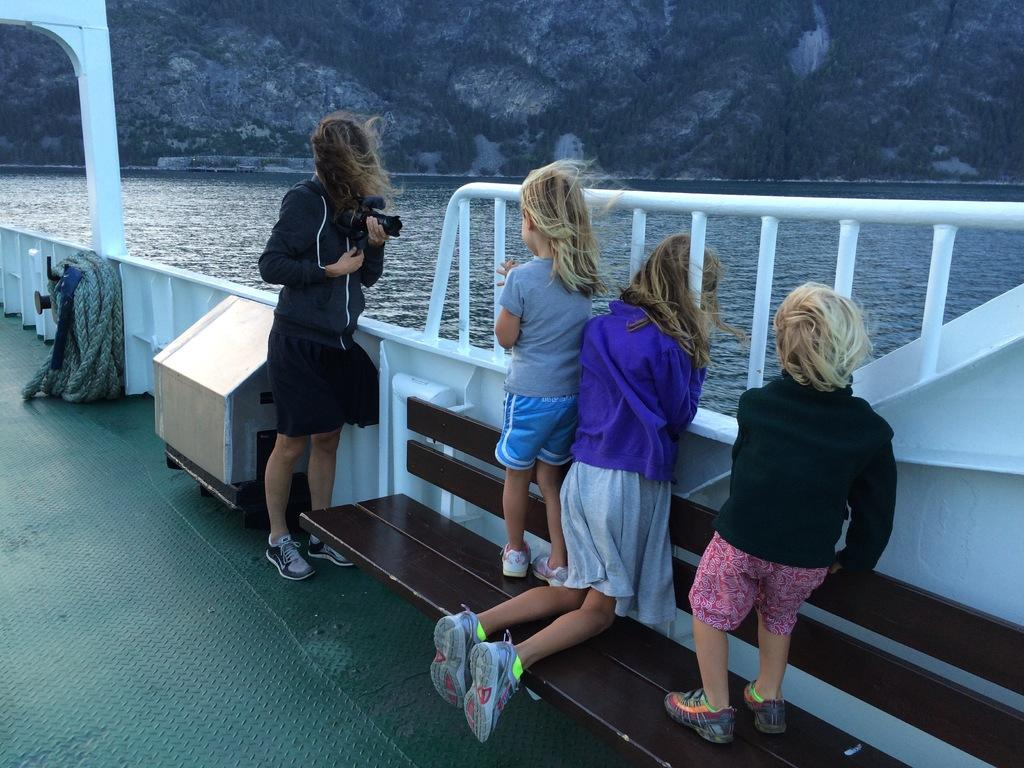How many people are in the image? There are people in the image, but the exact number is not specified. What can be observed about the clothing of the people in the image? The people are wearing different color dresses. What is one person doing in the image? One person is holding a camera. Where are the people located in the image? The people are inside a white boat. What is attached to the boat in the image? There is a rope visible in the image. What can be seen in the background of the image? There is water and mountains visible in the image. What type of plantation can be seen in the image? There is no plantation present in the image. How does the temper of the people in the image compare to the temper of the mountains? The temper of the people and the temper of the mountains cannot be compared, as the temper of inanimate objects like mountains is not applicable. 